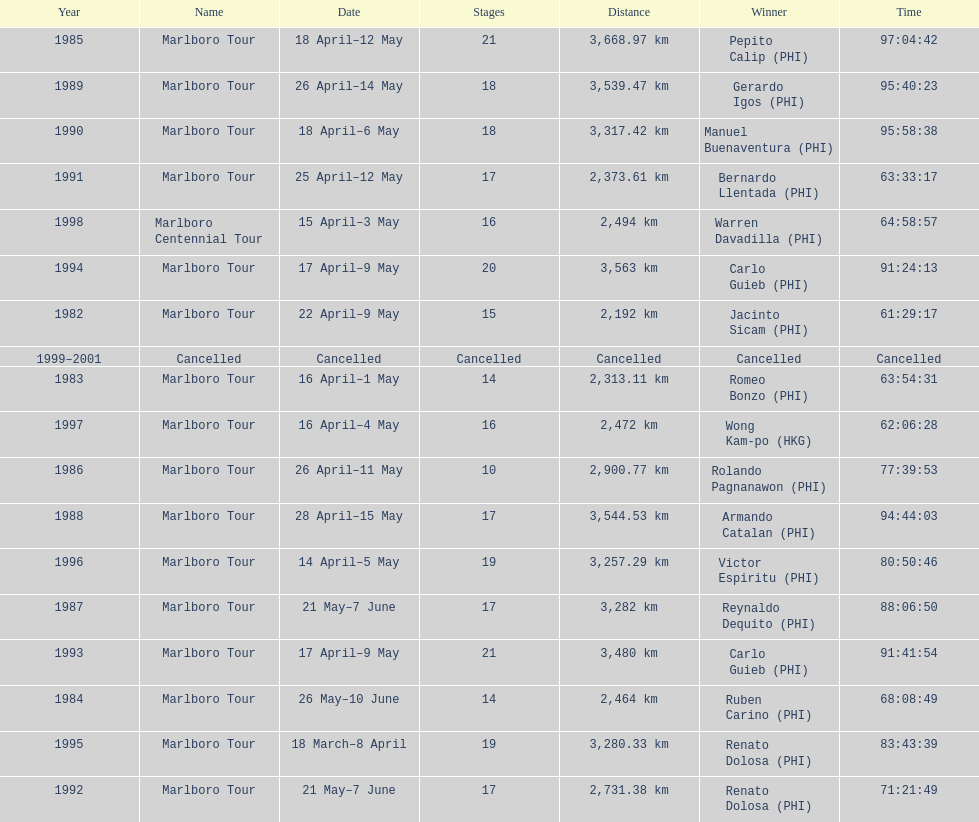Who won the most marlboro tours? Carlo Guieb. 